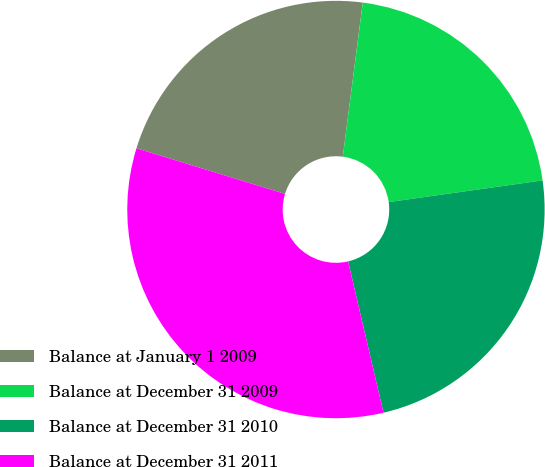Convert chart to OTSL. <chart><loc_0><loc_0><loc_500><loc_500><pie_chart><fcel>Balance at January 1 2009<fcel>Balance at December 31 2009<fcel>Balance at December 31 2010<fcel>Balance at December 31 2011<nl><fcel>22.31%<fcel>20.72%<fcel>23.57%<fcel>33.4%<nl></chart> 